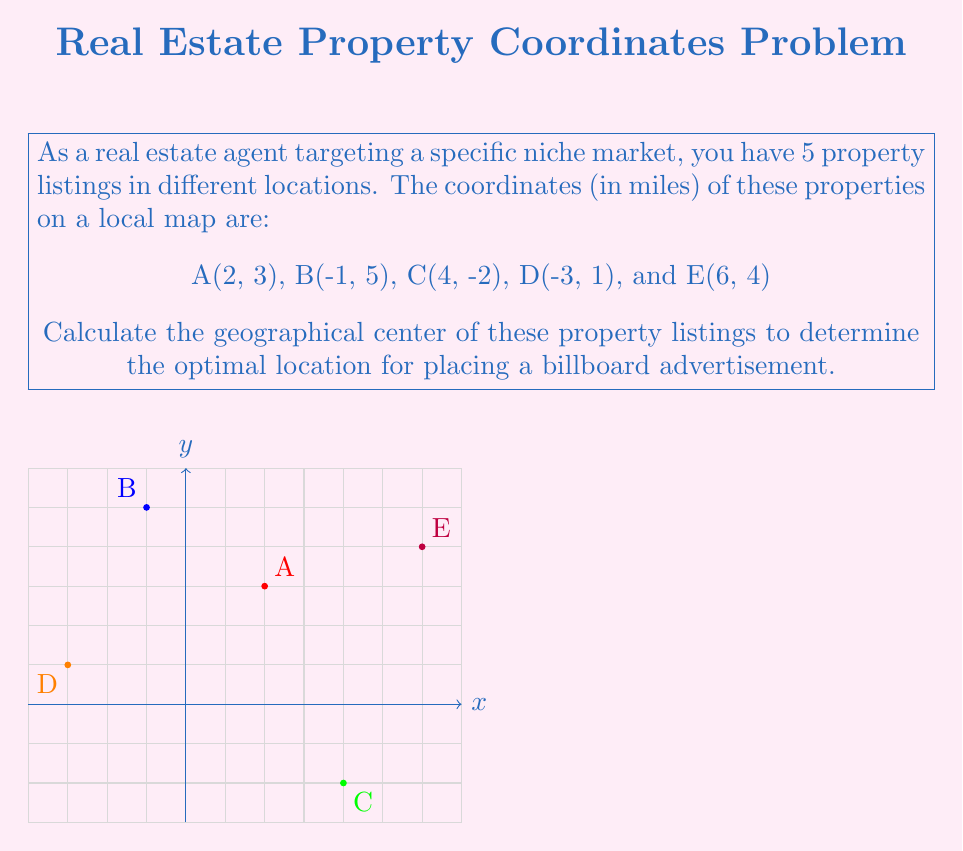Teach me how to tackle this problem. To find the geographical center of multiple points, we need to calculate the average of their x-coordinates and y-coordinates separately. This method is also known as finding the centroid.

Step 1: List all x-coordinates and y-coordinates separately.
x-coordinates: 2, -1, 4, -3, 6
y-coordinates: 3, 5, -2, 1, 4

Step 2: Calculate the average x-coordinate.
$$\bar{x} = \frac{2 + (-1) + 4 + (-3) + 6}{5} = \frac{8}{5} = 1.6$$

Step 3: Calculate the average y-coordinate.
$$\bar{y} = \frac{3 + 5 + (-2) + 1 + 4}{5} = \frac{11}{5} = 2.2$$

Step 4: The geographical center is the point $(\bar{x}, \bar{y})$, which in this case is (1.6, 2.2).

This point represents the optimal location for placing a billboard advertisement to target the area where your property listings are concentrated.
Answer: (1.6, 2.2) 